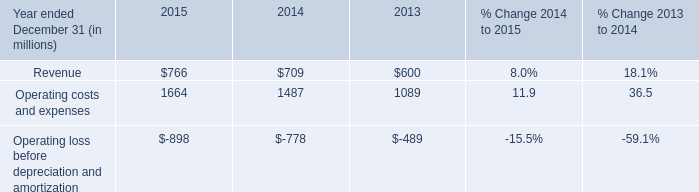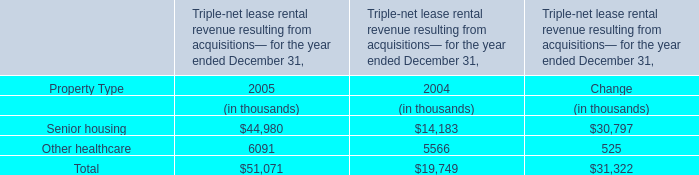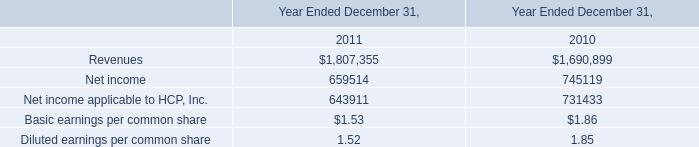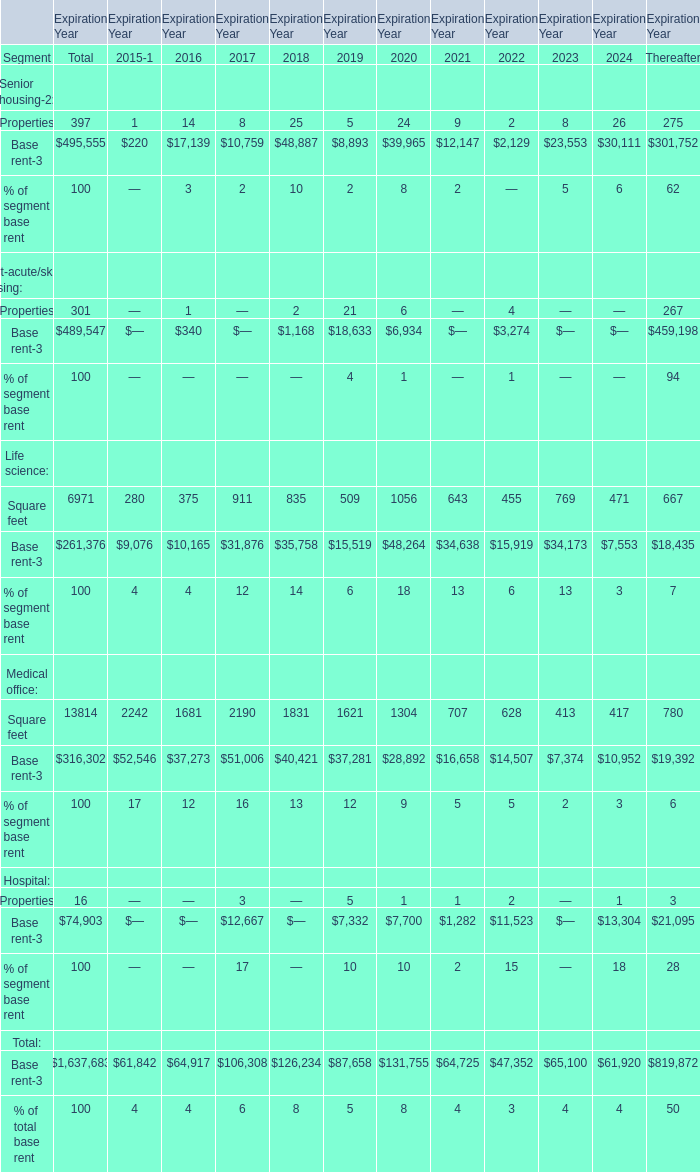What is the percentage of all Properties that are positive to the total amount, in 2016? 
Computations: (1 / ((((1 + 2) + 21) + 6) + 4))
Answer: 0.02941. 